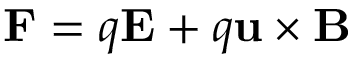Convert formula to latex. <formula><loc_0><loc_0><loc_500><loc_500>F = q E + q u \times B</formula> 